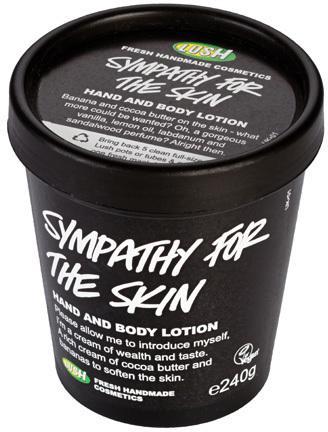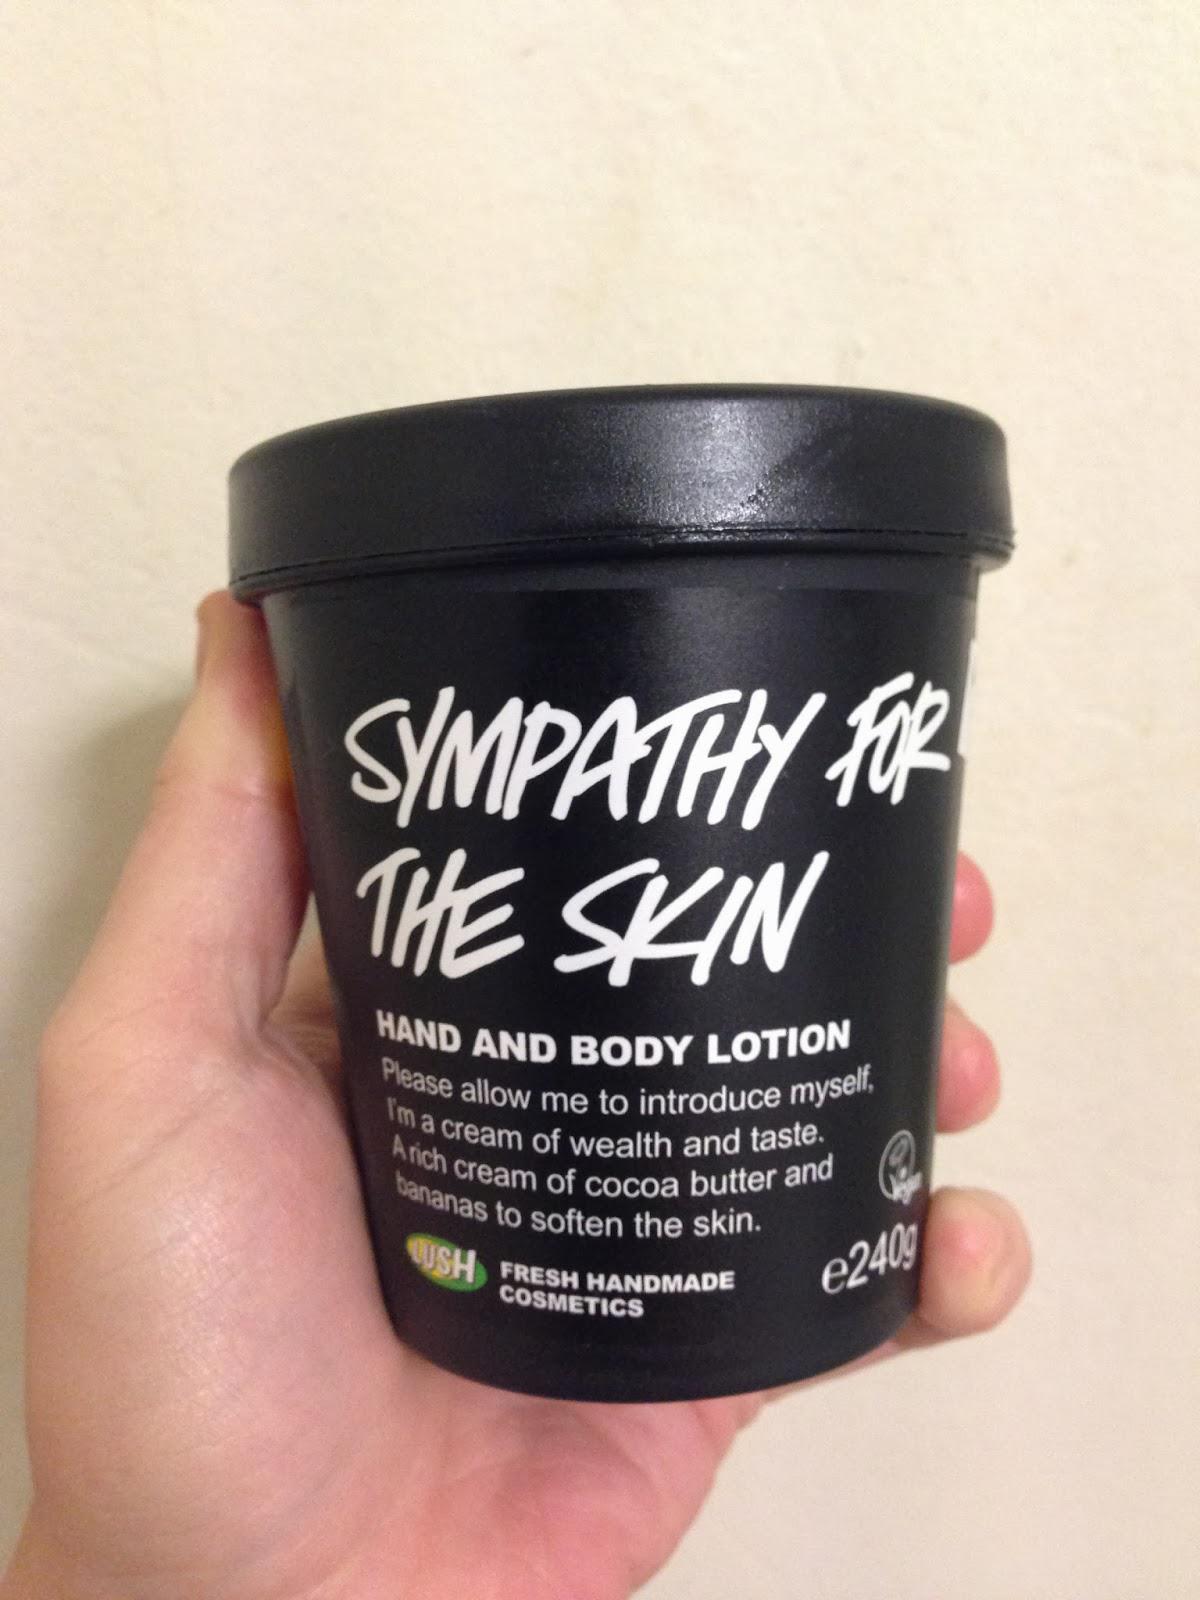The first image is the image on the left, the second image is the image on the right. Evaluate the accuracy of this statement regarding the images: "A lid is leaning next to one of the black tubs.". Is it true? Answer yes or no. No. The first image is the image on the left, the second image is the image on the right. Analyze the images presented: Is the assertion "In one image, the top is on the black tub, and in the other it is off, revealing a white cream inside" valid? Answer yes or no. No. 